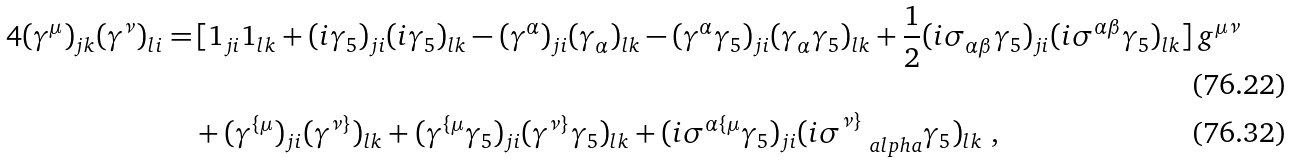<formula> <loc_0><loc_0><loc_500><loc_500>\, 4 ( \gamma ^ { \mu } ) _ { j k } ( \gamma ^ { \nu } ) _ { l i } = & \, [ { 1 } _ { j i } { 1 } _ { l k } + ( i \gamma _ { 5 } ) _ { j i } ( i \gamma _ { 5 } ) _ { l k } - ( \gamma ^ { \alpha } ) _ { j i } ( \gamma _ { \alpha } ) _ { l k } - ( \gamma ^ { \alpha } \gamma _ { 5 } ) _ { j i } ( \gamma _ { \alpha } \gamma _ { 5 } ) _ { l k } + \frac { 1 } { 2 } ( i \sigma _ { \alpha \beta } \gamma _ { 5 } ) _ { j i } ( i \sigma ^ { \alpha \beta } \gamma _ { 5 } ) _ { l k } ] \, g ^ { \mu \nu } \\ & + ( \gamma ^ { \{ \mu } ) _ { j i } ( \gamma ^ { \nu \} } ) _ { l k } + ( \gamma ^ { \{ \mu } \gamma _ { 5 } ) _ { j i } ( \gamma ^ { \nu \} } \gamma _ { 5 } ) _ { l k } + ( i \sigma ^ { \alpha \{ \mu } \gamma _ { 5 } ) _ { j i } ( i \sigma ^ { \nu \} } _ { \quad a l p h a } \gamma _ { 5 } ) _ { l k } \ ,</formula> 